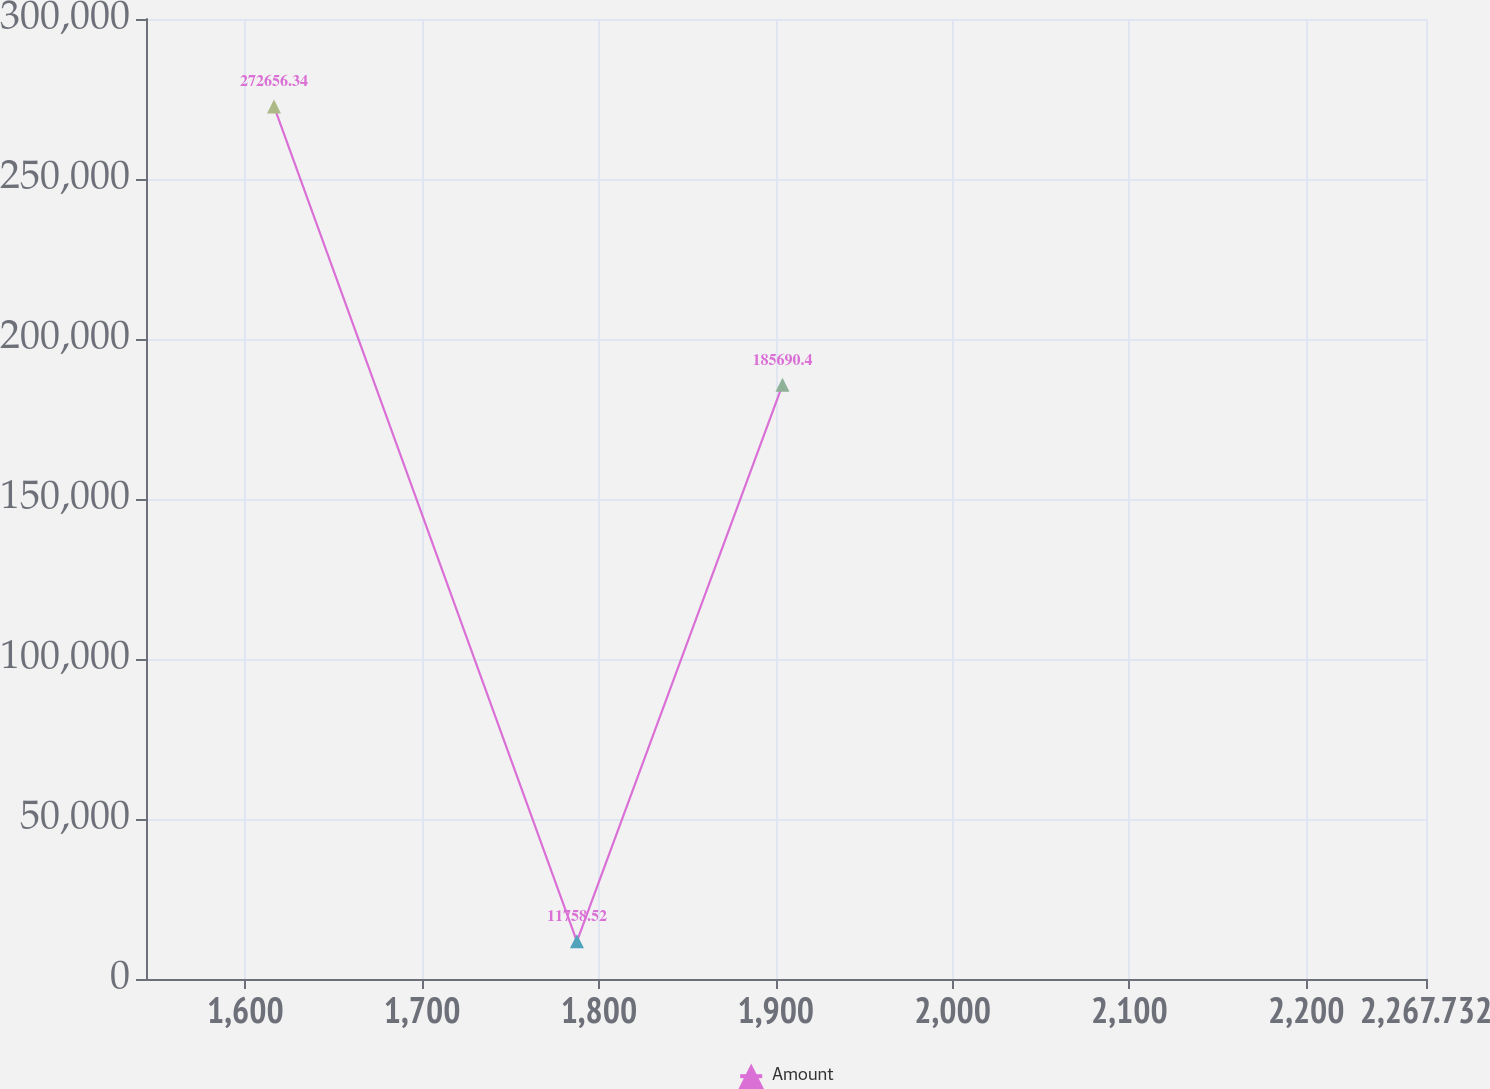Convert chart to OTSL. <chart><loc_0><loc_0><loc_500><loc_500><line_chart><ecel><fcel>Amount<nl><fcel>1616.24<fcel>272656<nl><fcel>1787.55<fcel>11758.5<nl><fcel>1903.82<fcel>185690<nl><fcel>2268.88<fcel>98724.5<nl><fcel>2340.12<fcel>881418<nl></chart> 